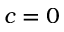Convert formula to latex. <formula><loc_0><loc_0><loc_500><loc_500>c = 0</formula> 